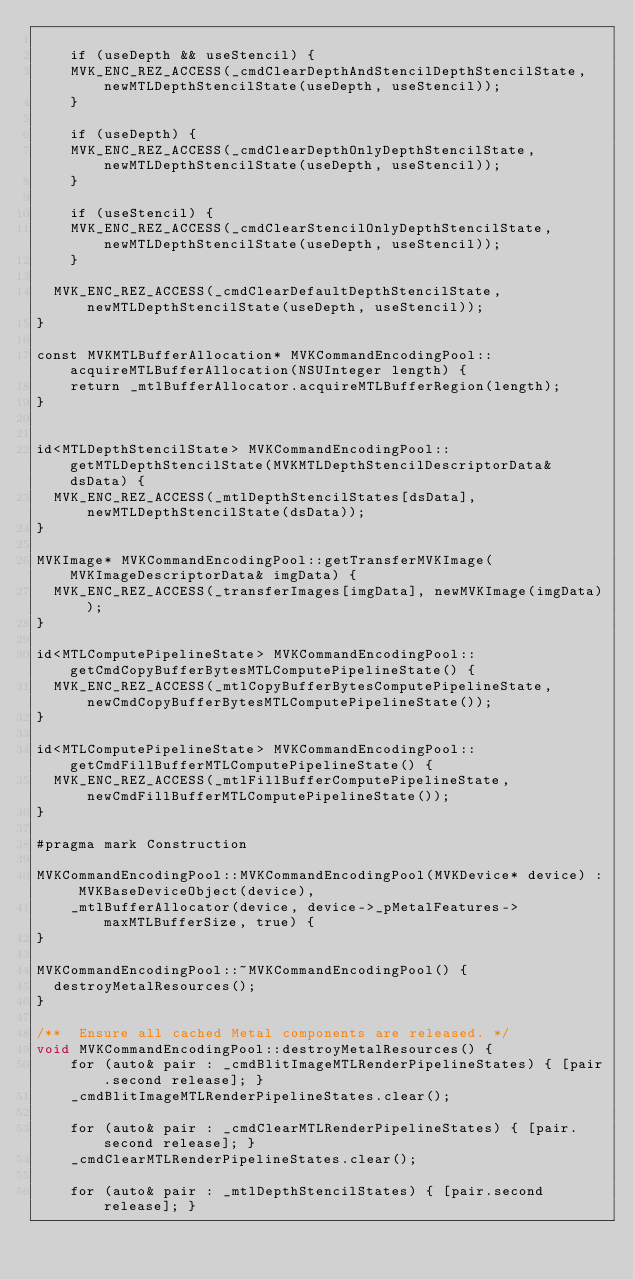Convert code to text. <code><loc_0><loc_0><loc_500><loc_500><_ObjectiveC_>
    if (useDepth && useStencil) {
		MVK_ENC_REZ_ACCESS(_cmdClearDepthAndStencilDepthStencilState, newMTLDepthStencilState(useDepth, useStencil));
    }

    if (useDepth) {
		MVK_ENC_REZ_ACCESS(_cmdClearDepthOnlyDepthStencilState, newMTLDepthStencilState(useDepth, useStencil));
    }

    if (useStencil) {
		MVK_ENC_REZ_ACCESS(_cmdClearStencilOnlyDepthStencilState, newMTLDepthStencilState(useDepth, useStencil));
    }

	MVK_ENC_REZ_ACCESS(_cmdClearDefaultDepthStencilState, newMTLDepthStencilState(useDepth, useStencil));
}

const MVKMTLBufferAllocation* MVKCommandEncodingPool::acquireMTLBufferAllocation(NSUInteger length) {
    return _mtlBufferAllocator.acquireMTLBufferRegion(length);
}


id<MTLDepthStencilState> MVKCommandEncodingPool::getMTLDepthStencilState(MVKMTLDepthStencilDescriptorData& dsData) {
	MVK_ENC_REZ_ACCESS(_mtlDepthStencilStates[dsData], newMTLDepthStencilState(dsData));
}

MVKImage* MVKCommandEncodingPool::getTransferMVKImage(MVKImageDescriptorData& imgData) {
	MVK_ENC_REZ_ACCESS(_transferImages[imgData], newMVKImage(imgData));
}

id<MTLComputePipelineState> MVKCommandEncodingPool::getCmdCopyBufferBytesMTLComputePipelineState() {
	MVK_ENC_REZ_ACCESS(_mtlCopyBufferBytesComputePipelineState, newCmdCopyBufferBytesMTLComputePipelineState());
}

id<MTLComputePipelineState> MVKCommandEncodingPool::getCmdFillBufferMTLComputePipelineState() {
	MVK_ENC_REZ_ACCESS(_mtlFillBufferComputePipelineState, newCmdFillBufferMTLComputePipelineState());
}

#pragma mark Construction

MVKCommandEncodingPool::MVKCommandEncodingPool(MVKDevice* device) : MVKBaseDeviceObject(device),
    _mtlBufferAllocator(device, device->_pMetalFeatures->maxMTLBufferSize, true) {
}

MVKCommandEncodingPool::~MVKCommandEncodingPool() {
	destroyMetalResources();
}

/**  Ensure all cached Metal components are released. */
void MVKCommandEncodingPool::destroyMetalResources() {
    for (auto& pair : _cmdBlitImageMTLRenderPipelineStates) { [pair.second release]; }
    _cmdBlitImageMTLRenderPipelineStates.clear();

    for (auto& pair : _cmdClearMTLRenderPipelineStates) { [pair.second release]; }
    _cmdClearMTLRenderPipelineStates.clear();

    for (auto& pair : _mtlDepthStencilStates) { [pair.second release]; }</code> 